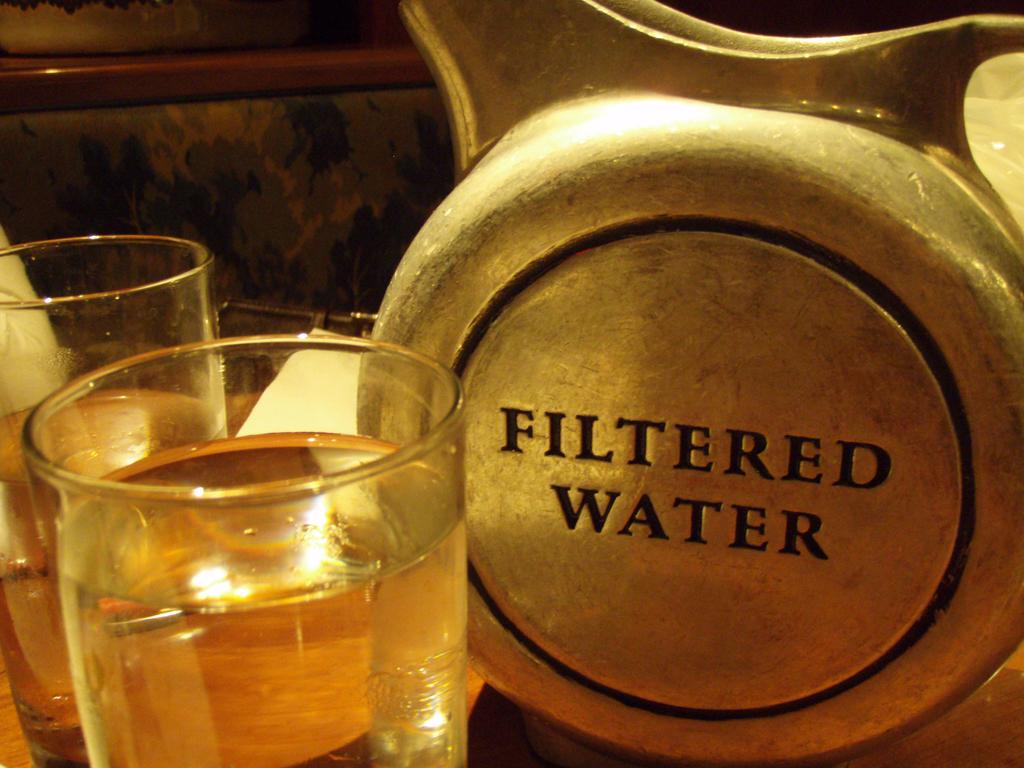What kind of water is this?
Offer a very short reply. Filtered. Is this water filtered?
Keep it short and to the point. Yes. 